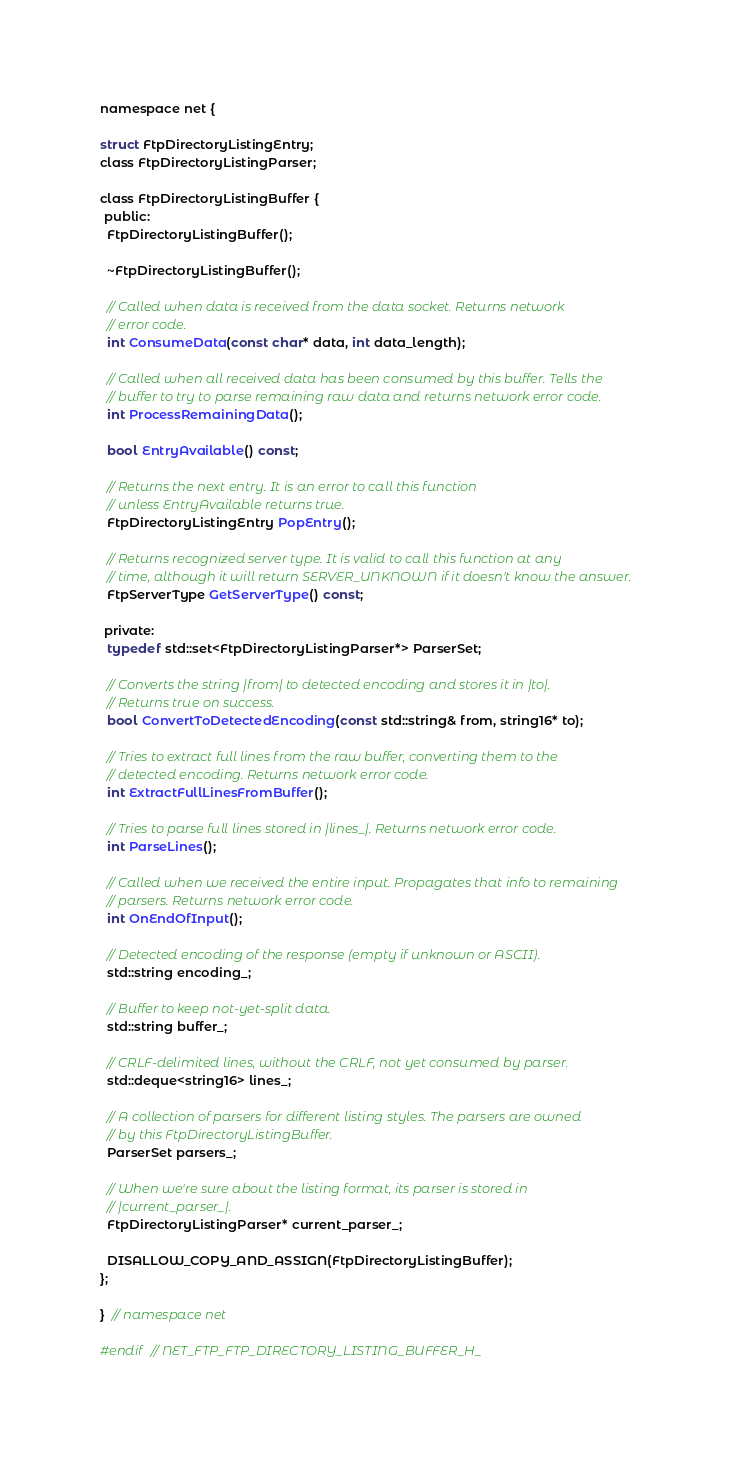Convert code to text. <code><loc_0><loc_0><loc_500><loc_500><_C_>namespace net {

struct FtpDirectoryListingEntry;
class FtpDirectoryListingParser;

class FtpDirectoryListingBuffer {
 public:
  FtpDirectoryListingBuffer();

  ~FtpDirectoryListingBuffer();

  // Called when data is received from the data socket. Returns network
  // error code.
  int ConsumeData(const char* data, int data_length);

  // Called when all received data has been consumed by this buffer. Tells the
  // buffer to try to parse remaining raw data and returns network error code.
  int ProcessRemainingData();

  bool EntryAvailable() const;

  // Returns the next entry. It is an error to call this function
  // unless EntryAvailable returns true.
  FtpDirectoryListingEntry PopEntry();

  // Returns recognized server type. It is valid to call this function at any
  // time, although it will return SERVER_UNKNOWN if it doesn't know the answer.
  FtpServerType GetServerType() const;

 private:
  typedef std::set<FtpDirectoryListingParser*> ParserSet;

  // Converts the string |from| to detected encoding and stores it in |to|.
  // Returns true on success.
  bool ConvertToDetectedEncoding(const std::string& from, string16* to);

  // Tries to extract full lines from the raw buffer, converting them to the
  // detected encoding. Returns network error code.
  int ExtractFullLinesFromBuffer();

  // Tries to parse full lines stored in |lines_|. Returns network error code.
  int ParseLines();

  // Called when we received the entire input. Propagates that info to remaining
  // parsers. Returns network error code.
  int OnEndOfInput();

  // Detected encoding of the response (empty if unknown or ASCII).
  std::string encoding_;

  // Buffer to keep not-yet-split data.
  std::string buffer_;

  // CRLF-delimited lines, without the CRLF, not yet consumed by parser.
  std::deque<string16> lines_;

  // A collection of parsers for different listing styles. The parsers are owned
  // by this FtpDirectoryListingBuffer.
  ParserSet parsers_;

  // When we're sure about the listing format, its parser is stored in
  // |current_parser_|.
  FtpDirectoryListingParser* current_parser_;

  DISALLOW_COPY_AND_ASSIGN(FtpDirectoryListingBuffer);
};

}  // namespace net

#endif  // NET_FTP_FTP_DIRECTORY_LISTING_BUFFER_H_
</code> 